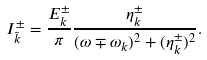Convert formula to latex. <formula><loc_0><loc_0><loc_500><loc_500>I _ { \bar { k } } ^ { \pm } = \frac { E _ { k } ^ { \pm } } { \pi } \frac { \eta _ { k } ^ { \pm } } { ( \omega \mp \omega _ { k } ) ^ { 2 } + ( { \eta _ { k } ^ { \pm } } ) ^ { 2 } } .</formula> 